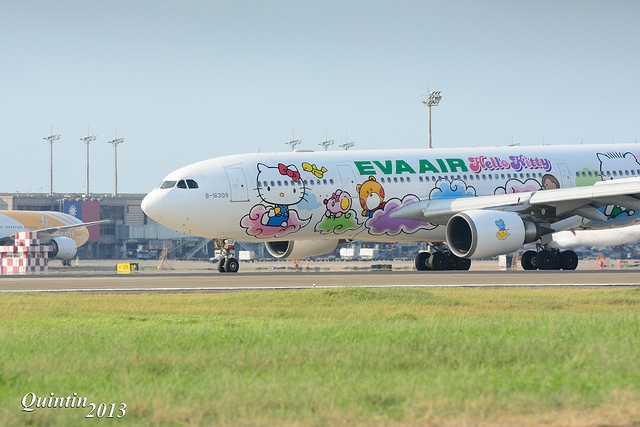Describe the objects in this image and their specific colors. I can see airplane in lightblue, lightgray, darkgray, and gray tones and airplane in lightblue, darkgray, gray, and tan tones in this image. 